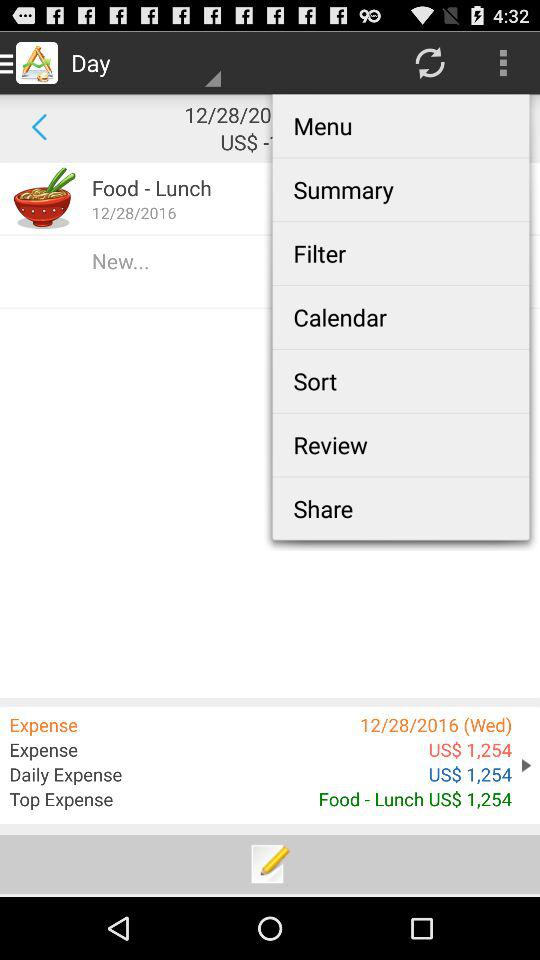What is the date of the expense? The date of the expense is Wednesday, December 28, 2016. 